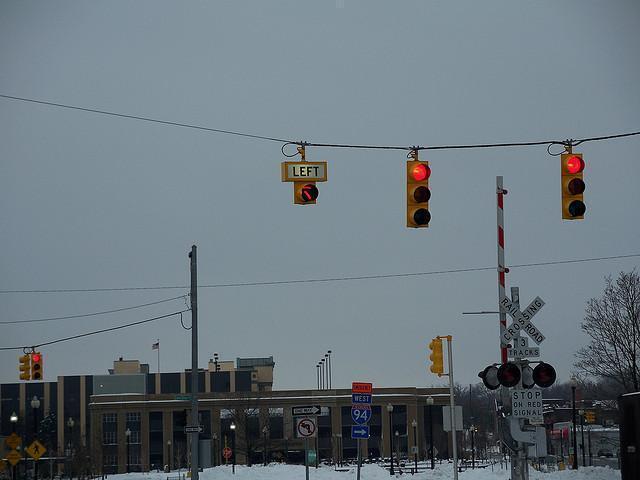What vehicle makes frequent crosses at this intersection?
Make your selection from the four choices given to correctly answer the question.
Options: Train, plane, motorcycle, trolley. Train. 